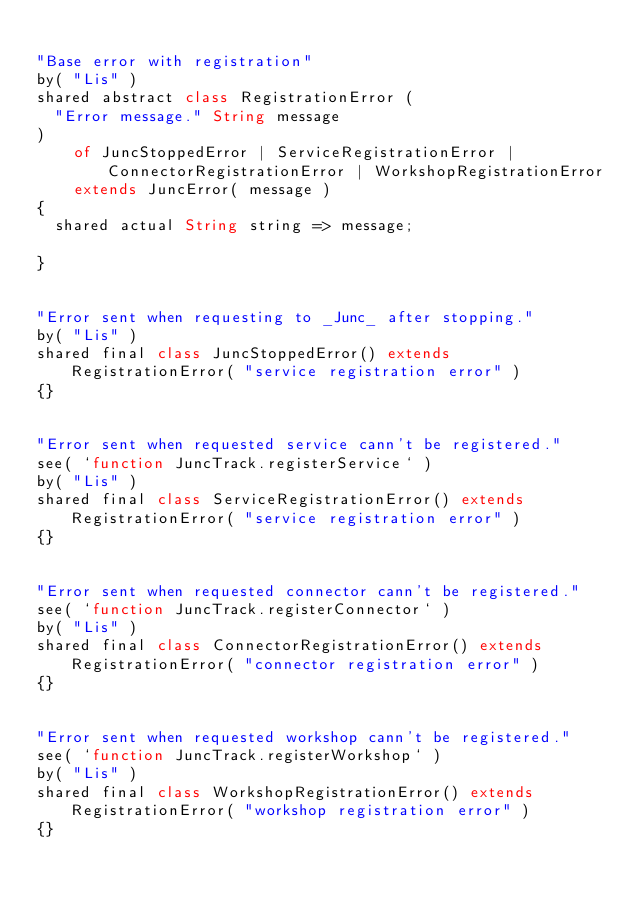<code> <loc_0><loc_0><loc_500><loc_500><_Ceylon_>
"Base error with registration"
by( "Lis" )
shared abstract class RegistrationError (
	"Error message." String message
)
		of JuncStoppedError | ServiceRegistrationError | ConnectorRegistrationError | WorkshopRegistrationError
		extends JuncError( message )
{
	shared actual String string => message;
	
}


"Error sent when requesting to _Junc_ after stopping."
by( "Lis" )
shared final class JuncStoppedError() extends RegistrationError( "service registration error" )
{}


"Error sent when requested service cann't be registered."
see( `function JuncTrack.registerService` )
by( "Lis" )
shared final class ServiceRegistrationError() extends RegistrationError( "service registration error" )
{}


"Error sent when requested connector cann't be registered."
see( `function JuncTrack.registerConnector` )
by( "Lis" )
shared final class ConnectorRegistrationError() extends RegistrationError( "connector registration error" )
{}


"Error sent when requested workshop cann't be registered."
see( `function JuncTrack.registerWorkshop` )
by( "Lis" )
shared final class WorkshopRegistrationError() extends RegistrationError( "workshop registration error" )
{}

</code> 